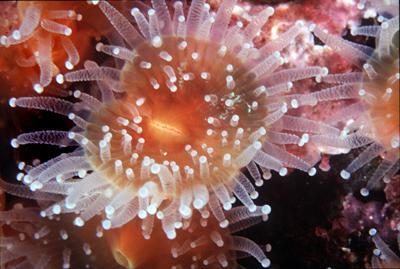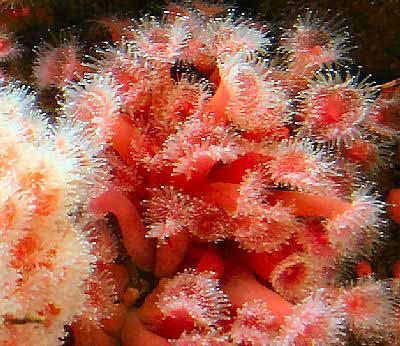The first image is the image on the left, the second image is the image on the right. Evaluate the accuracy of this statement regarding the images: "The base of the anemone is red in the image on the right.". Is it true? Answer yes or no. Yes. The first image is the image on the left, the second image is the image on the right. Examine the images to the left and right. Is the description "At least one of the images shows more than one anemone." accurate? Answer yes or no. Yes. 